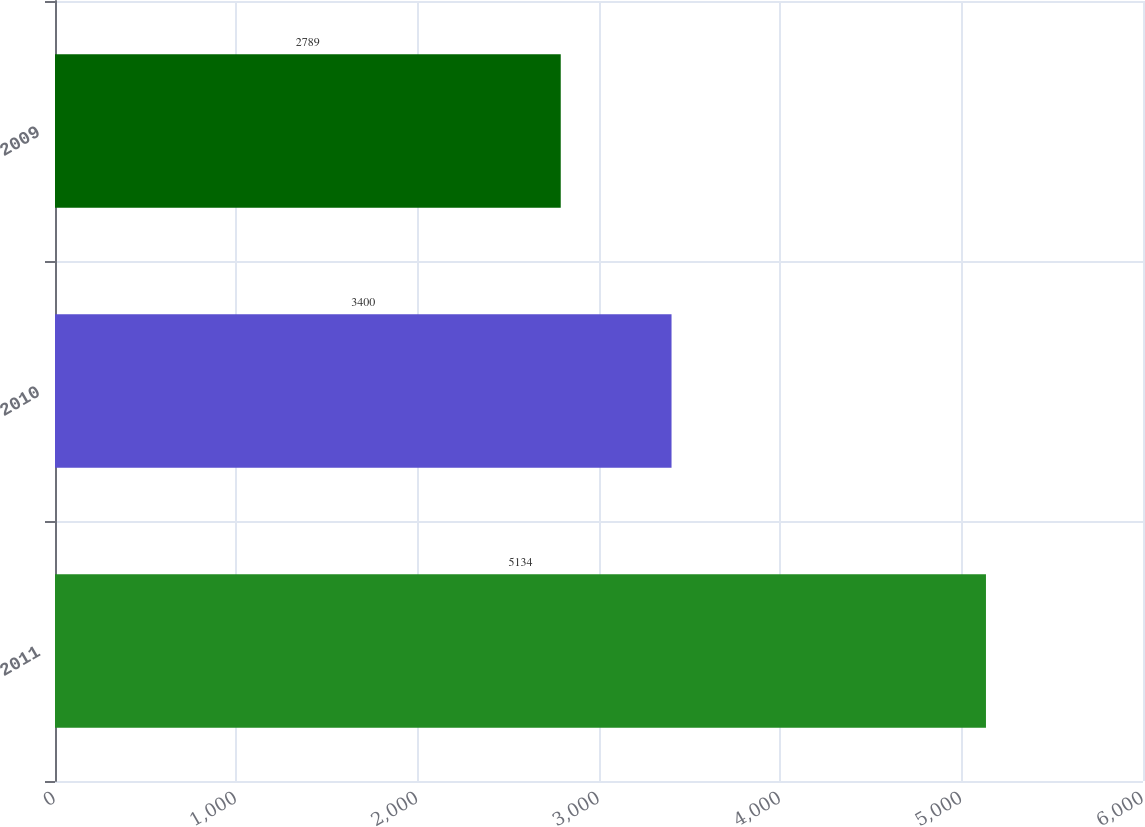<chart> <loc_0><loc_0><loc_500><loc_500><bar_chart><fcel>2011<fcel>2010<fcel>2009<nl><fcel>5134<fcel>3400<fcel>2789<nl></chart> 